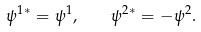<formula> <loc_0><loc_0><loc_500><loc_500>\psi ^ { 1 * } = \psi ^ { 1 } , \quad \psi ^ { 2 * } = - \psi ^ { 2 } .</formula> 